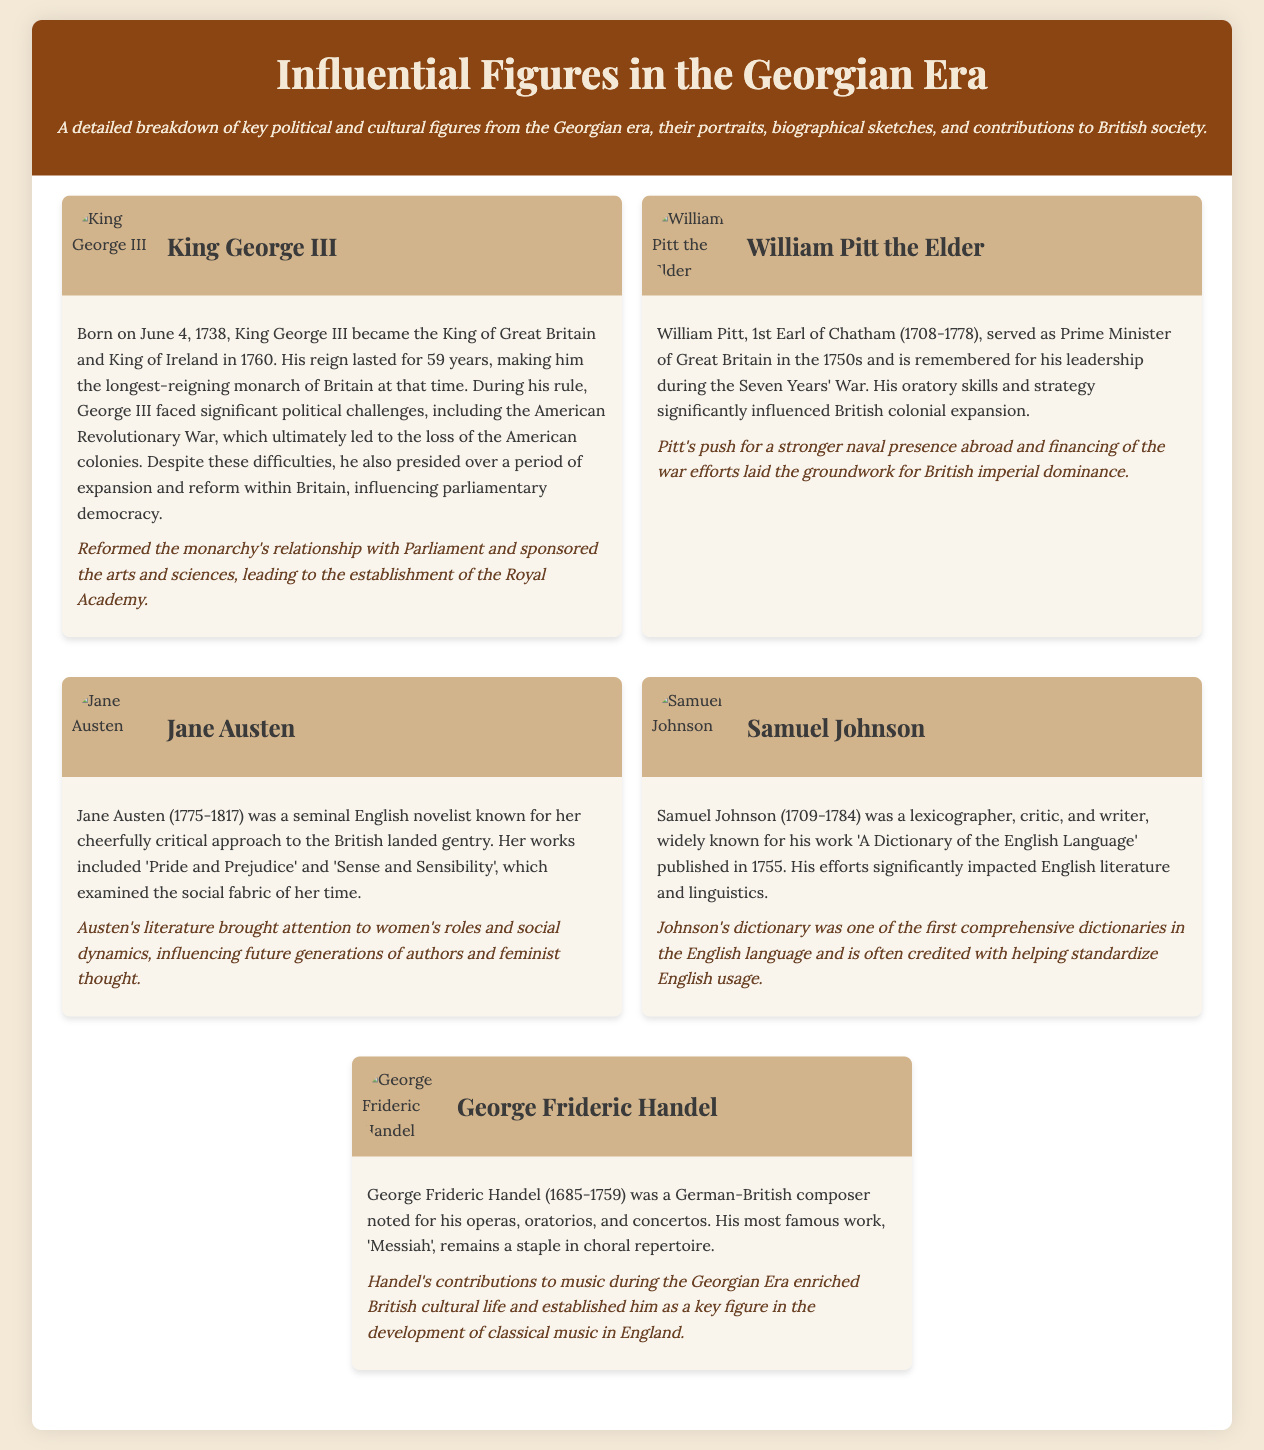What is the birth date of King George III? King George III was born on June 4, 1738, as stated in his biographical section.
Answer: June 4, 1738 Who served as Prime Minister during the Seven Years' War? William Pitt the Elder is noted for his leadership during the Seven Years' War in the document.
Answer: William Pitt the Elder What was a significant work of Samuel Johnson? The document highlights 'A Dictionary of the English Language' as a key achievement of Samuel Johnson.
Answer: A Dictionary of the English Language Which novel is NOT authored by Jane Austen? The document lists specific works by Jane Austen, and any mentioned work that isn't one of those is excluded.
Answer: Any work not listed such as "Wuthering Heights." In what year was Jane Austen born? Jane Austen's birth year is provided as 1775 in her biographical sketch.
Answer: 1775 What notable piece of music did George Frideric Handel compose? The document identifies 'Messiah' as Handel's most famous work, indicating its significance.
Answer: Messiah How long did King George III reign? The document states that King George III's reign lasted for 59 years, making it a prominent detail.
Answer: 59 years Which figure is known for influencing feminist thought? Jane Austen's contributions to literature and women's roles indicate her influence on feminist thought as per the document.
Answer: Jane Austen What is the document structured as? The document consists of a catalog detailing influential figures, focusing on their portraits, biographies, and contributions.
Answer: Catalog 